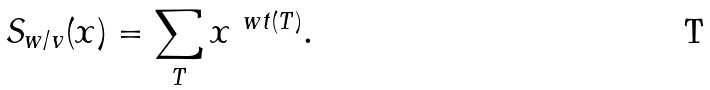<formula> <loc_0><loc_0><loc_500><loc_500>S _ { w / v } ( x ) = \sum _ { T } x ^ { \ w t ( T ) } .</formula> 